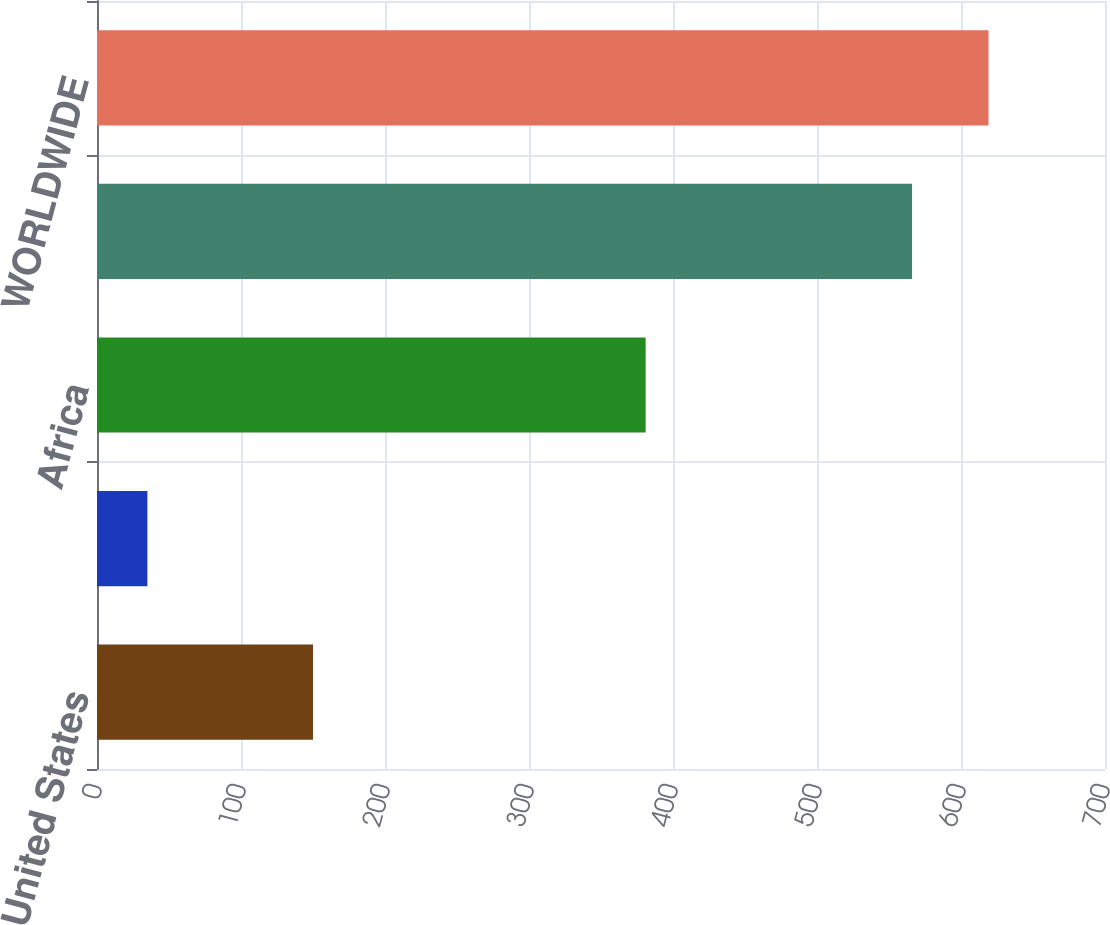Convert chart. <chart><loc_0><loc_0><loc_500><loc_500><bar_chart><fcel>United States<fcel>Europe<fcel>Africa<fcel>Worldwide Continuing<fcel>WORLDWIDE<nl><fcel>150<fcel>35<fcel>381<fcel>566<fcel>619.1<nl></chart> 